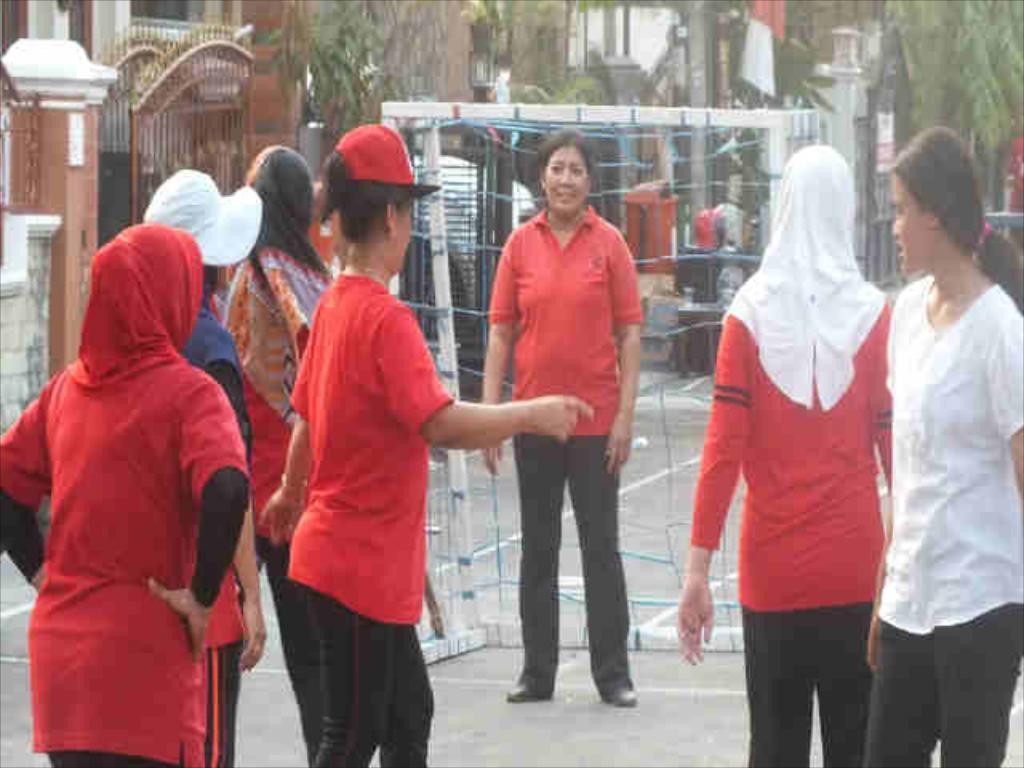Can you describe this image briefly? As we can see in the image there are few people here and there, trees, gates and there are buildings. 